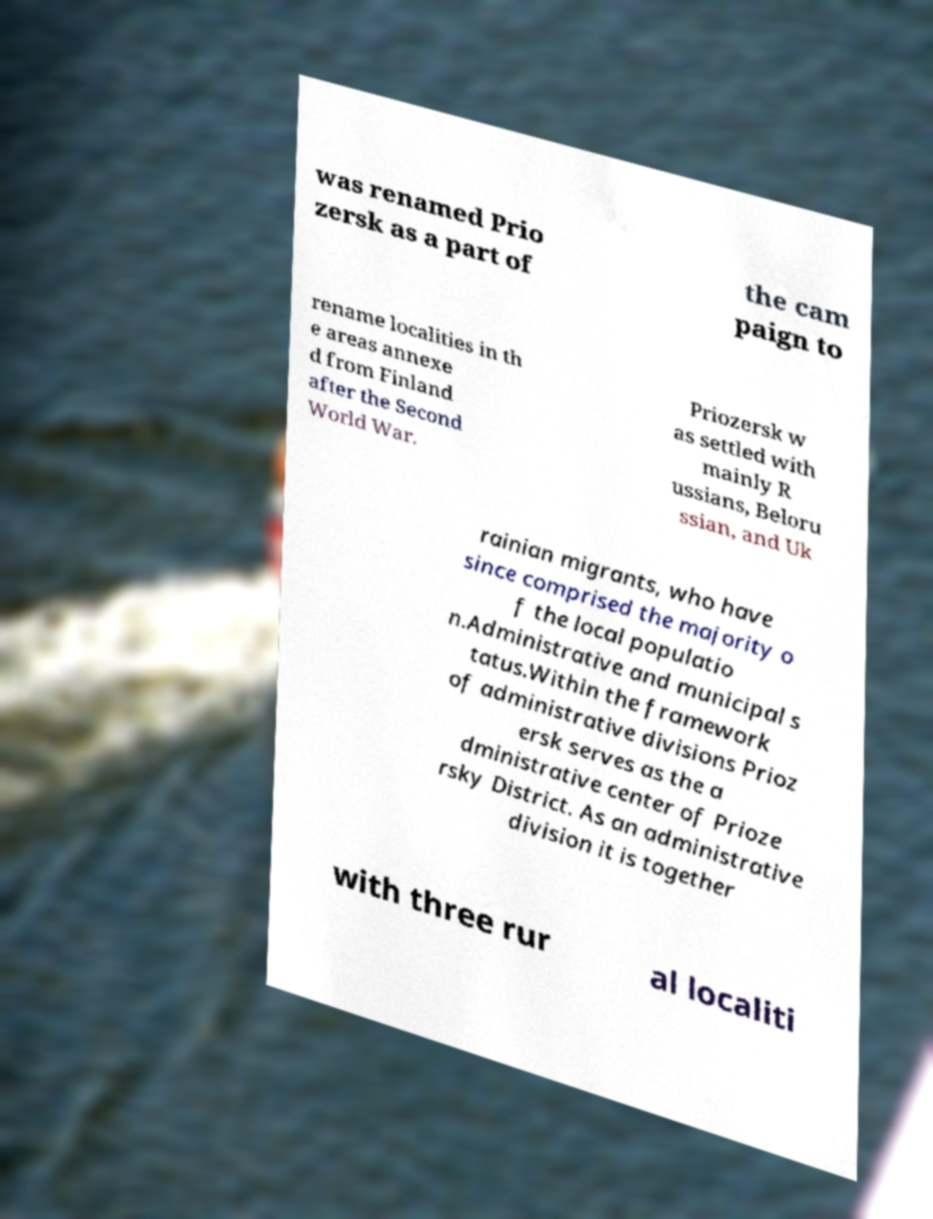I need the written content from this picture converted into text. Can you do that? was renamed Prio zersk as a part of the cam paign to rename localities in th e areas annexe d from Finland after the Second World War. Priozersk w as settled with mainly R ussians, Beloru ssian, and Uk rainian migrants, who have since comprised the majority o f the local populatio n.Administrative and municipal s tatus.Within the framework of administrative divisions Prioz ersk serves as the a dministrative center of Prioze rsky District. As an administrative division it is together with three rur al localiti 